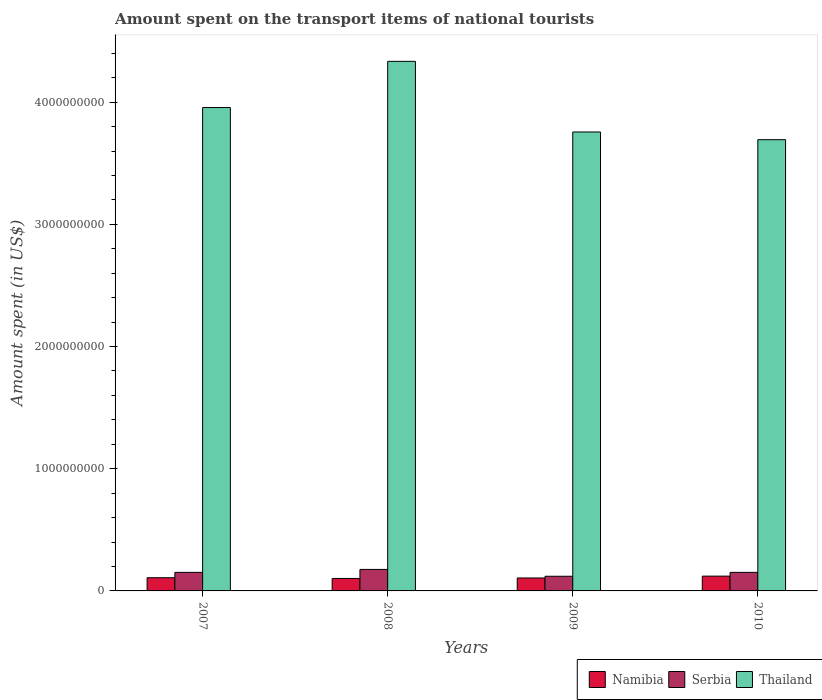How many groups of bars are there?
Give a very brief answer. 4. Are the number of bars per tick equal to the number of legend labels?
Provide a succinct answer. Yes. How many bars are there on the 3rd tick from the left?
Keep it short and to the point. 3. How many bars are there on the 4th tick from the right?
Provide a short and direct response. 3. In how many cases, is the number of bars for a given year not equal to the number of legend labels?
Make the answer very short. 0. What is the amount spent on the transport items of national tourists in Thailand in 2009?
Provide a short and direct response. 3.76e+09. Across all years, what is the maximum amount spent on the transport items of national tourists in Namibia?
Offer a very short reply. 1.21e+08. Across all years, what is the minimum amount spent on the transport items of national tourists in Serbia?
Keep it short and to the point. 1.20e+08. In which year was the amount spent on the transport items of national tourists in Serbia maximum?
Your answer should be compact. 2008. What is the total amount spent on the transport items of national tourists in Serbia in the graph?
Offer a terse response. 6.00e+08. What is the difference between the amount spent on the transport items of national tourists in Thailand in 2009 and that in 2010?
Your response must be concise. 6.30e+07. What is the difference between the amount spent on the transport items of national tourists in Thailand in 2010 and the amount spent on the transport items of national tourists in Namibia in 2009?
Your response must be concise. 3.59e+09. What is the average amount spent on the transport items of national tourists in Thailand per year?
Your response must be concise. 3.93e+09. In the year 2008, what is the difference between the amount spent on the transport items of national tourists in Serbia and amount spent on the transport items of national tourists in Namibia?
Offer a terse response. 7.40e+07. In how many years, is the amount spent on the transport items of national tourists in Namibia greater than 1400000000 US$?
Offer a terse response. 0. What is the ratio of the amount spent on the transport items of national tourists in Namibia in 2007 to that in 2008?
Your answer should be compact. 1.06. Is the difference between the amount spent on the transport items of national tourists in Serbia in 2007 and 2008 greater than the difference between the amount spent on the transport items of national tourists in Namibia in 2007 and 2008?
Make the answer very short. No. What is the difference between the highest and the second highest amount spent on the transport items of national tourists in Namibia?
Offer a very short reply. 1.30e+07. What is the difference between the highest and the lowest amount spent on the transport items of national tourists in Thailand?
Offer a terse response. 6.41e+08. In how many years, is the amount spent on the transport items of national tourists in Thailand greater than the average amount spent on the transport items of national tourists in Thailand taken over all years?
Make the answer very short. 2. What does the 3rd bar from the left in 2010 represents?
Ensure brevity in your answer.  Thailand. What does the 2nd bar from the right in 2007 represents?
Your answer should be very brief. Serbia. Does the graph contain grids?
Provide a succinct answer. No. Where does the legend appear in the graph?
Provide a short and direct response. Bottom right. How many legend labels are there?
Make the answer very short. 3. How are the legend labels stacked?
Offer a very short reply. Horizontal. What is the title of the graph?
Your answer should be very brief. Amount spent on the transport items of national tourists. What is the label or title of the X-axis?
Provide a short and direct response. Years. What is the label or title of the Y-axis?
Give a very brief answer. Amount spent (in US$). What is the Amount spent (in US$) of Namibia in 2007?
Offer a very short reply. 1.08e+08. What is the Amount spent (in US$) of Serbia in 2007?
Offer a very short reply. 1.52e+08. What is the Amount spent (in US$) of Thailand in 2007?
Offer a very short reply. 3.96e+09. What is the Amount spent (in US$) of Namibia in 2008?
Provide a succinct answer. 1.02e+08. What is the Amount spent (in US$) in Serbia in 2008?
Ensure brevity in your answer.  1.76e+08. What is the Amount spent (in US$) of Thailand in 2008?
Ensure brevity in your answer.  4.33e+09. What is the Amount spent (in US$) of Namibia in 2009?
Your response must be concise. 1.06e+08. What is the Amount spent (in US$) in Serbia in 2009?
Your answer should be compact. 1.20e+08. What is the Amount spent (in US$) of Thailand in 2009?
Make the answer very short. 3.76e+09. What is the Amount spent (in US$) of Namibia in 2010?
Your answer should be very brief. 1.21e+08. What is the Amount spent (in US$) of Serbia in 2010?
Ensure brevity in your answer.  1.52e+08. What is the Amount spent (in US$) in Thailand in 2010?
Offer a very short reply. 3.69e+09. Across all years, what is the maximum Amount spent (in US$) in Namibia?
Give a very brief answer. 1.21e+08. Across all years, what is the maximum Amount spent (in US$) of Serbia?
Make the answer very short. 1.76e+08. Across all years, what is the maximum Amount spent (in US$) of Thailand?
Your answer should be very brief. 4.33e+09. Across all years, what is the minimum Amount spent (in US$) in Namibia?
Ensure brevity in your answer.  1.02e+08. Across all years, what is the minimum Amount spent (in US$) in Serbia?
Provide a short and direct response. 1.20e+08. Across all years, what is the minimum Amount spent (in US$) of Thailand?
Make the answer very short. 3.69e+09. What is the total Amount spent (in US$) of Namibia in the graph?
Ensure brevity in your answer.  4.37e+08. What is the total Amount spent (in US$) of Serbia in the graph?
Offer a very short reply. 6.00e+08. What is the total Amount spent (in US$) of Thailand in the graph?
Keep it short and to the point. 1.57e+1. What is the difference between the Amount spent (in US$) of Serbia in 2007 and that in 2008?
Your answer should be very brief. -2.40e+07. What is the difference between the Amount spent (in US$) of Thailand in 2007 and that in 2008?
Provide a succinct answer. -3.78e+08. What is the difference between the Amount spent (in US$) in Namibia in 2007 and that in 2009?
Keep it short and to the point. 2.00e+06. What is the difference between the Amount spent (in US$) in Serbia in 2007 and that in 2009?
Your answer should be very brief. 3.20e+07. What is the difference between the Amount spent (in US$) of Thailand in 2007 and that in 2009?
Ensure brevity in your answer.  2.00e+08. What is the difference between the Amount spent (in US$) in Namibia in 2007 and that in 2010?
Ensure brevity in your answer.  -1.30e+07. What is the difference between the Amount spent (in US$) in Serbia in 2007 and that in 2010?
Offer a very short reply. 0. What is the difference between the Amount spent (in US$) of Thailand in 2007 and that in 2010?
Provide a succinct answer. 2.63e+08. What is the difference between the Amount spent (in US$) in Namibia in 2008 and that in 2009?
Your answer should be compact. -4.00e+06. What is the difference between the Amount spent (in US$) in Serbia in 2008 and that in 2009?
Provide a succinct answer. 5.60e+07. What is the difference between the Amount spent (in US$) of Thailand in 2008 and that in 2009?
Ensure brevity in your answer.  5.78e+08. What is the difference between the Amount spent (in US$) of Namibia in 2008 and that in 2010?
Offer a very short reply. -1.90e+07. What is the difference between the Amount spent (in US$) in Serbia in 2008 and that in 2010?
Make the answer very short. 2.40e+07. What is the difference between the Amount spent (in US$) of Thailand in 2008 and that in 2010?
Give a very brief answer. 6.41e+08. What is the difference between the Amount spent (in US$) of Namibia in 2009 and that in 2010?
Provide a short and direct response. -1.50e+07. What is the difference between the Amount spent (in US$) of Serbia in 2009 and that in 2010?
Keep it short and to the point. -3.20e+07. What is the difference between the Amount spent (in US$) in Thailand in 2009 and that in 2010?
Offer a terse response. 6.30e+07. What is the difference between the Amount spent (in US$) in Namibia in 2007 and the Amount spent (in US$) in Serbia in 2008?
Make the answer very short. -6.80e+07. What is the difference between the Amount spent (in US$) of Namibia in 2007 and the Amount spent (in US$) of Thailand in 2008?
Your answer should be compact. -4.23e+09. What is the difference between the Amount spent (in US$) of Serbia in 2007 and the Amount spent (in US$) of Thailand in 2008?
Keep it short and to the point. -4.18e+09. What is the difference between the Amount spent (in US$) in Namibia in 2007 and the Amount spent (in US$) in Serbia in 2009?
Provide a short and direct response. -1.20e+07. What is the difference between the Amount spent (in US$) of Namibia in 2007 and the Amount spent (in US$) of Thailand in 2009?
Your answer should be very brief. -3.65e+09. What is the difference between the Amount spent (in US$) of Serbia in 2007 and the Amount spent (in US$) of Thailand in 2009?
Your answer should be compact. -3.60e+09. What is the difference between the Amount spent (in US$) in Namibia in 2007 and the Amount spent (in US$) in Serbia in 2010?
Give a very brief answer. -4.40e+07. What is the difference between the Amount spent (in US$) of Namibia in 2007 and the Amount spent (in US$) of Thailand in 2010?
Provide a short and direct response. -3.58e+09. What is the difference between the Amount spent (in US$) of Serbia in 2007 and the Amount spent (in US$) of Thailand in 2010?
Your answer should be compact. -3.54e+09. What is the difference between the Amount spent (in US$) of Namibia in 2008 and the Amount spent (in US$) of Serbia in 2009?
Your answer should be very brief. -1.80e+07. What is the difference between the Amount spent (in US$) in Namibia in 2008 and the Amount spent (in US$) in Thailand in 2009?
Provide a succinct answer. -3.65e+09. What is the difference between the Amount spent (in US$) in Serbia in 2008 and the Amount spent (in US$) in Thailand in 2009?
Keep it short and to the point. -3.58e+09. What is the difference between the Amount spent (in US$) of Namibia in 2008 and the Amount spent (in US$) of Serbia in 2010?
Provide a short and direct response. -5.00e+07. What is the difference between the Amount spent (in US$) in Namibia in 2008 and the Amount spent (in US$) in Thailand in 2010?
Make the answer very short. -3.59e+09. What is the difference between the Amount spent (in US$) in Serbia in 2008 and the Amount spent (in US$) in Thailand in 2010?
Make the answer very short. -3.52e+09. What is the difference between the Amount spent (in US$) in Namibia in 2009 and the Amount spent (in US$) in Serbia in 2010?
Keep it short and to the point. -4.60e+07. What is the difference between the Amount spent (in US$) in Namibia in 2009 and the Amount spent (in US$) in Thailand in 2010?
Your response must be concise. -3.59e+09. What is the difference between the Amount spent (in US$) of Serbia in 2009 and the Amount spent (in US$) of Thailand in 2010?
Your answer should be very brief. -3.57e+09. What is the average Amount spent (in US$) of Namibia per year?
Your answer should be compact. 1.09e+08. What is the average Amount spent (in US$) of Serbia per year?
Keep it short and to the point. 1.50e+08. What is the average Amount spent (in US$) of Thailand per year?
Provide a succinct answer. 3.93e+09. In the year 2007, what is the difference between the Amount spent (in US$) in Namibia and Amount spent (in US$) in Serbia?
Keep it short and to the point. -4.40e+07. In the year 2007, what is the difference between the Amount spent (in US$) in Namibia and Amount spent (in US$) in Thailand?
Offer a very short reply. -3.85e+09. In the year 2007, what is the difference between the Amount spent (in US$) of Serbia and Amount spent (in US$) of Thailand?
Offer a very short reply. -3.80e+09. In the year 2008, what is the difference between the Amount spent (in US$) of Namibia and Amount spent (in US$) of Serbia?
Offer a very short reply. -7.40e+07. In the year 2008, what is the difference between the Amount spent (in US$) in Namibia and Amount spent (in US$) in Thailand?
Give a very brief answer. -4.23e+09. In the year 2008, what is the difference between the Amount spent (in US$) in Serbia and Amount spent (in US$) in Thailand?
Your answer should be very brief. -4.16e+09. In the year 2009, what is the difference between the Amount spent (in US$) of Namibia and Amount spent (in US$) of Serbia?
Provide a succinct answer. -1.40e+07. In the year 2009, what is the difference between the Amount spent (in US$) in Namibia and Amount spent (in US$) in Thailand?
Offer a very short reply. -3.65e+09. In the year 2009, what is the difference between the Amount spent (in US$) of Serbia and Amount spent (in US$) of Thailand?
Your response must be concise. -3.64e+09. In the year 2010, what is the difference between the Amount spent (in US$) of Namibia and Amount spent (in US$) of Serbia?
Give a very brief answer. -3.10e+07. In the year 2010, what is the difference between the Amount spent (in US$) in Namibia and Amount spent (in US$) in Thailand?
Ensure brevity in your answer.  -3.57e+09. In the year 2010, what is the difference between the Amount spent (in US$) of Serbia and Amount spent (in US$) of Thailand?
Offer a terse response. -3.54e+09. What is the ratio of the Amount spent (in US$) of Namibia in 2007 to that in 2008?
Offer a very short reply. 1.06. What is the ratio of the Amount spent (in US$) of Serbia in 2007 to that in 2008?
Offer a terse response. 0.86. What is the ratio of the Amount spent (in US$) in Thailand in 2007 to that in 2008?
Ensure brevity in your answer.  0.91. What is the ratio of the Amount spent (in US$) of Namibia in 2007 to that in 2009?
Offer a very short reply. 1.02. What is the ratio of the Amount spent (in US$) in Serbia in 2007 to that in 2009?
Offer a very short reply. 1.27. What is the ratio of the Amount spent (in US$) of Thailand in 2007 to that in 2009?
Keep it short and to the point. 1.05. What is the ratio of the Amount spent (in US$) of Namibia in 2007 to that in 2010?
Ensure brevity in your answer.  0.89. What is the ratio of the Amount spent (in US$) of Serbia in 2007 to that in 2010?
Make the answer very short. 1. What is the ratio of the Amount spent (in US$) in Thailand in 2007 to that in 2010?
Offer a terse response. 1.07. What is the ratio of the Amount spent (in US$) of Namibia in 2008 to that in 2009?
Provide a short and direct response. 0.96. What is the ratio of the Amount spent (in US$) of Serbia in 2008 to that in 2009?
Keep it short and to the point. 1.47. What is the ratio of the Amount spent (in US$) of Thailand in 2008 to that in 2009?
Ensure brevity in your answer.  1.15. What is the ratio of the Amount spent (in US$) of Namibia in 2008 to that in 2010?
Your response must be concise. 0.84. What is the ratio of the Amount spent (in US$) of Serbia in 2008 to that in 2010?
Offer a very short reply. 1.16. What is the ratio of the Amount spent (in US$) in Thailand in 2008 to that in 2010?
Your answer should be compact. 1.17. What is the ratio of the Amount spent (in US$) in Namibia in 2009 to that in 2010?
Offer a terse response. 0.88. What is the ratio of the Amount spent (in US$) in Serbia in 2009 to that in 2010?
Provide a short and direct response. 0.79. What is the ratio of the Amount spent (in US$) in Thailand in 2009 to that in 2010?
Keep it short and to the point. 1.02. What is the difference between the highest and the second highest Amount spent (in US$) in Namibia?
Your answer should be very brief. 1.30e+07. What is the difference between the highest and the second highest Amount spent (in US$) of Serbia?
Keep it short and to the point. 2.40e+07. What is the difference between the highest and the second highest Amount spent (in US$) in Thailand?
Offer a very short reply. 3.78e+08. What is the difference between the highest and the lowest Amount spent (in US$) in Namibia?
Offer a very short reply. 1.90e+07. What is the difference between the highest and the lowest Amount spent (in US$) in Serbia?
Make the answer very short. 5.60e+07. What is the difference between the highest and the lowest Amount spent (in US$) of Thailand?
Your answer should be compact. 6.41e+08. 